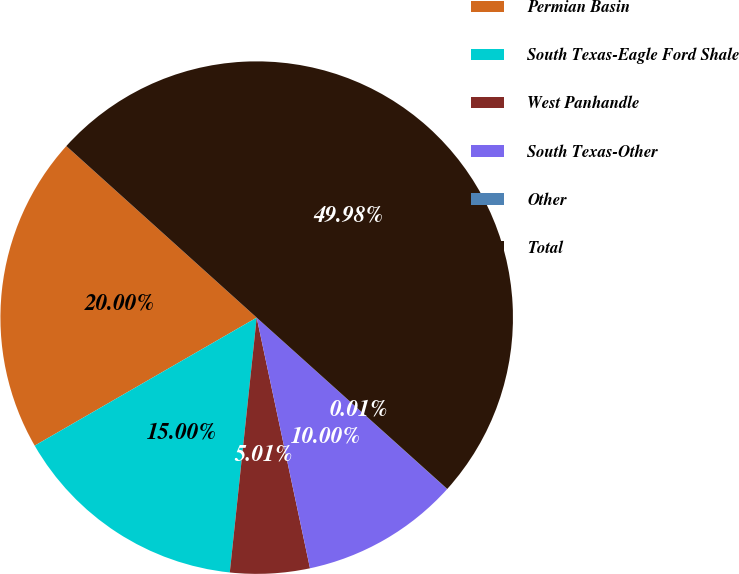<chart> <loc_0><loc_0><loc_500><loc_500><pie_chart><fcel>Permian Basin<fcel>South Texas-Eagle Ford Shale<fcel>West Panhandle<fcel>South Texas-Other<fcel>Other<fcel>Total<nl><fcel>20.0%<fcel>15.0%<fcel>5.01%<fcel>10.0%<fcel>0.01%<fcel>49.98%<nl></chart> 